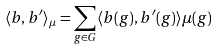Convert formula to latex. <formula><loc_0><loc_0><loc_500><loc_500>\langle b , b ^ { \prime } \rangle _ { \mu } = \sum _ { g \in G } \langle b ( g ) , b ^ { \prime } ( g ) \rangle \mu ( g )</formula> 